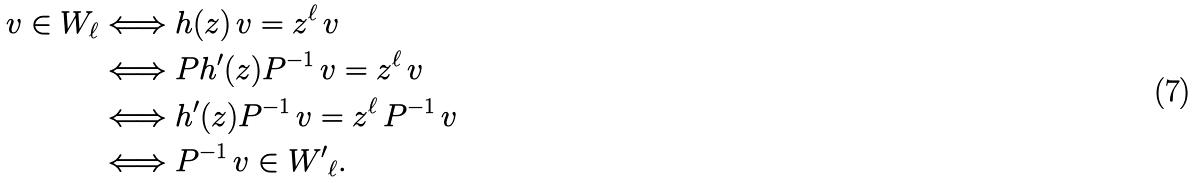<formula> <loc_0><loc_0><loc_500><loc_500>v \in W _ { \ell } & \Longleftrightarrow h ( z ) \, v = z ^ { \ell } \, v \\ & \Longleftrightarrow P h ^ { \prime } ( z ) P ^ { - 1 } \, v = z ^ { \ell } \, v \\ & \Longleftrightarrow h ^ { \prime } ( z ) P ^ { - 1 } \, v = z ^ { \ell } \, P ^ { - 1 } \, v \\ & \Longleftrightarrow P ^ { - 1 } \, v \in { W ^ { \prime } } _ { \ell } .</formula> 